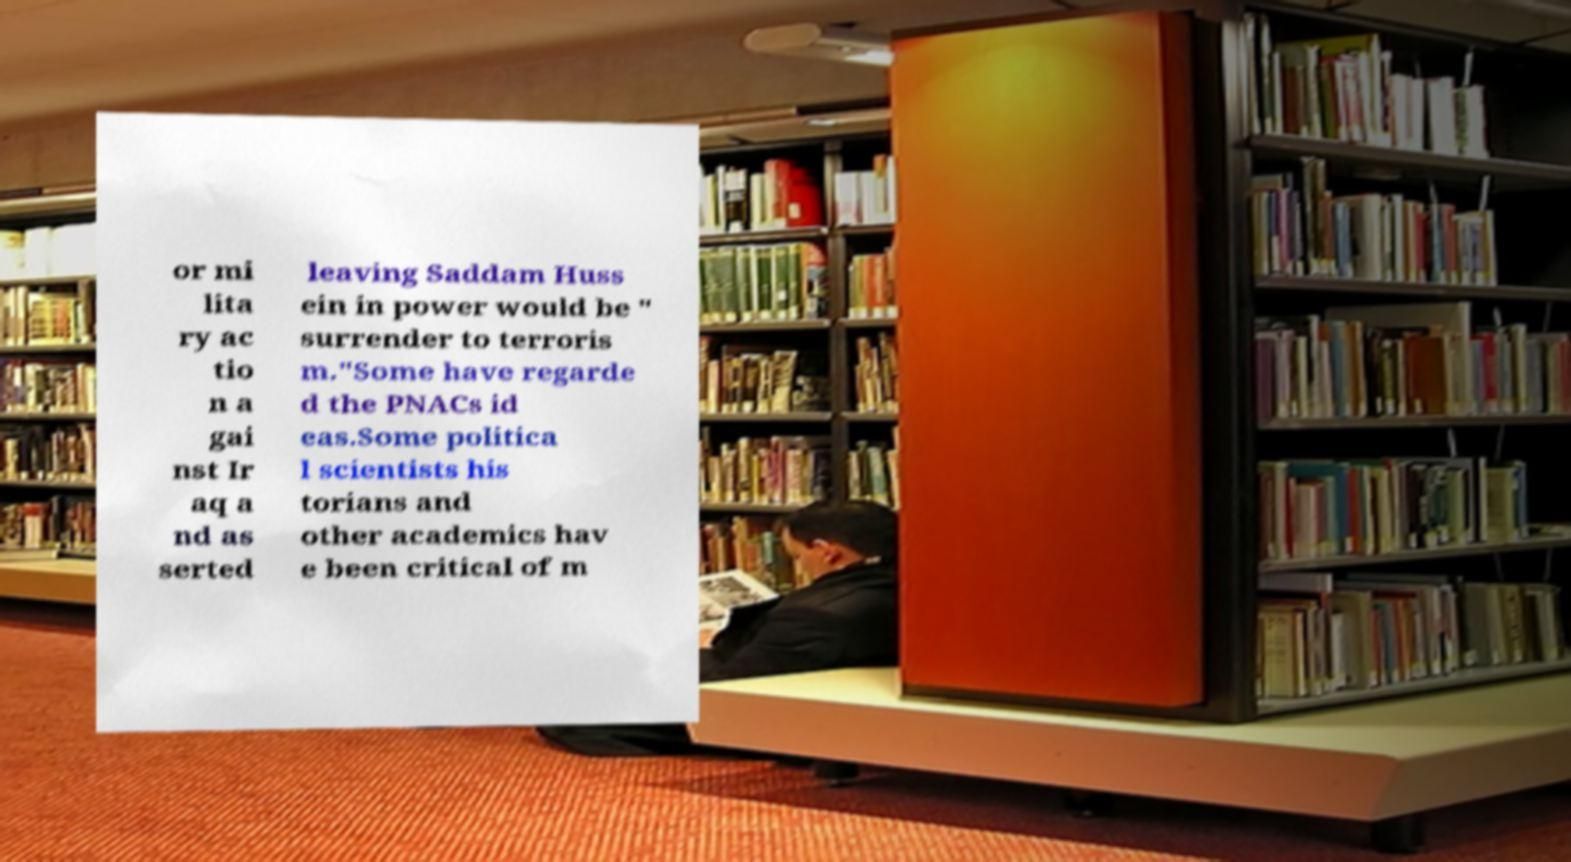There's text embedded in this image that I need extracted. Can you transcribe it verbatim? or mi lita ry ac tio n a gai nst Ir aq a nd as serted leaving Saddam Huss ein in power would be " surrender to terroris m."Some have regarde d the PNACs id eas.Some politica l scientists his torians and other academics hav e been critical of m 